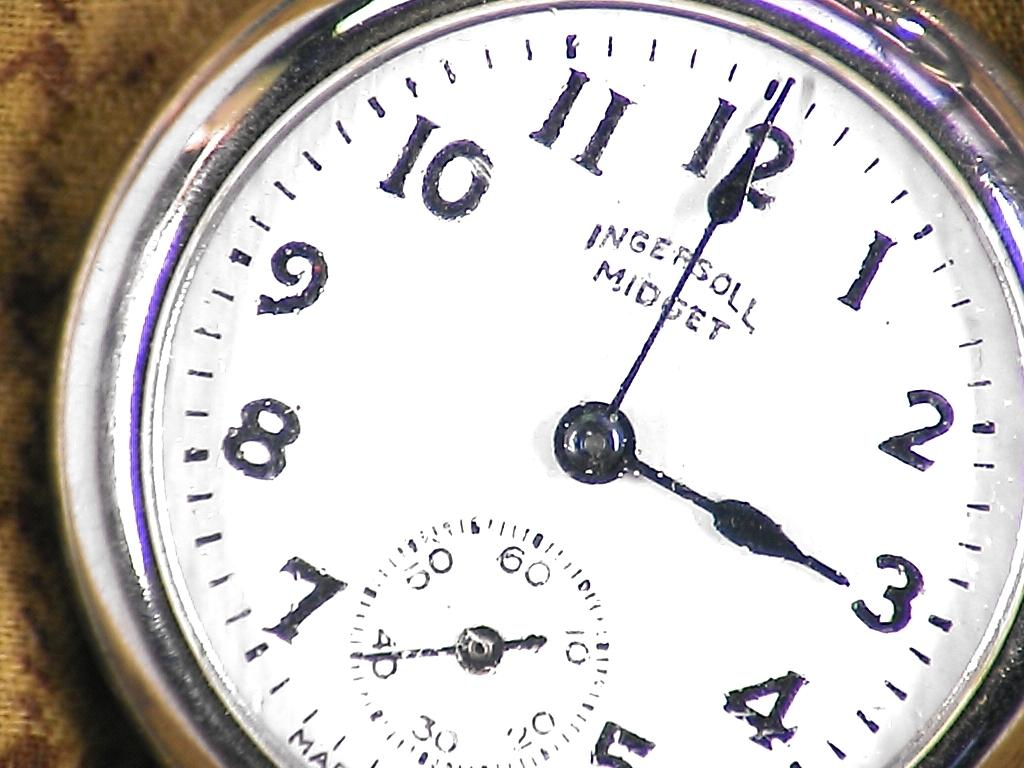<image>
Describe the image concisely. the numbers 1 to 12 that are on a clock 